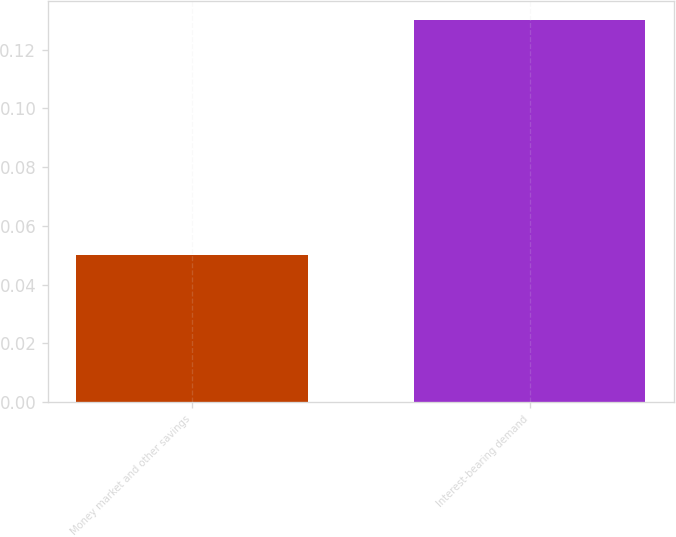Convert chart to OTSL. <chart><loc_0><loc_0><loc_500><loc_500><bar_chart><fcel>Money market and other savings<fcel>Interest-bearing demand<nl><fcel>0.05<fcel>0.13<nl></chart> 